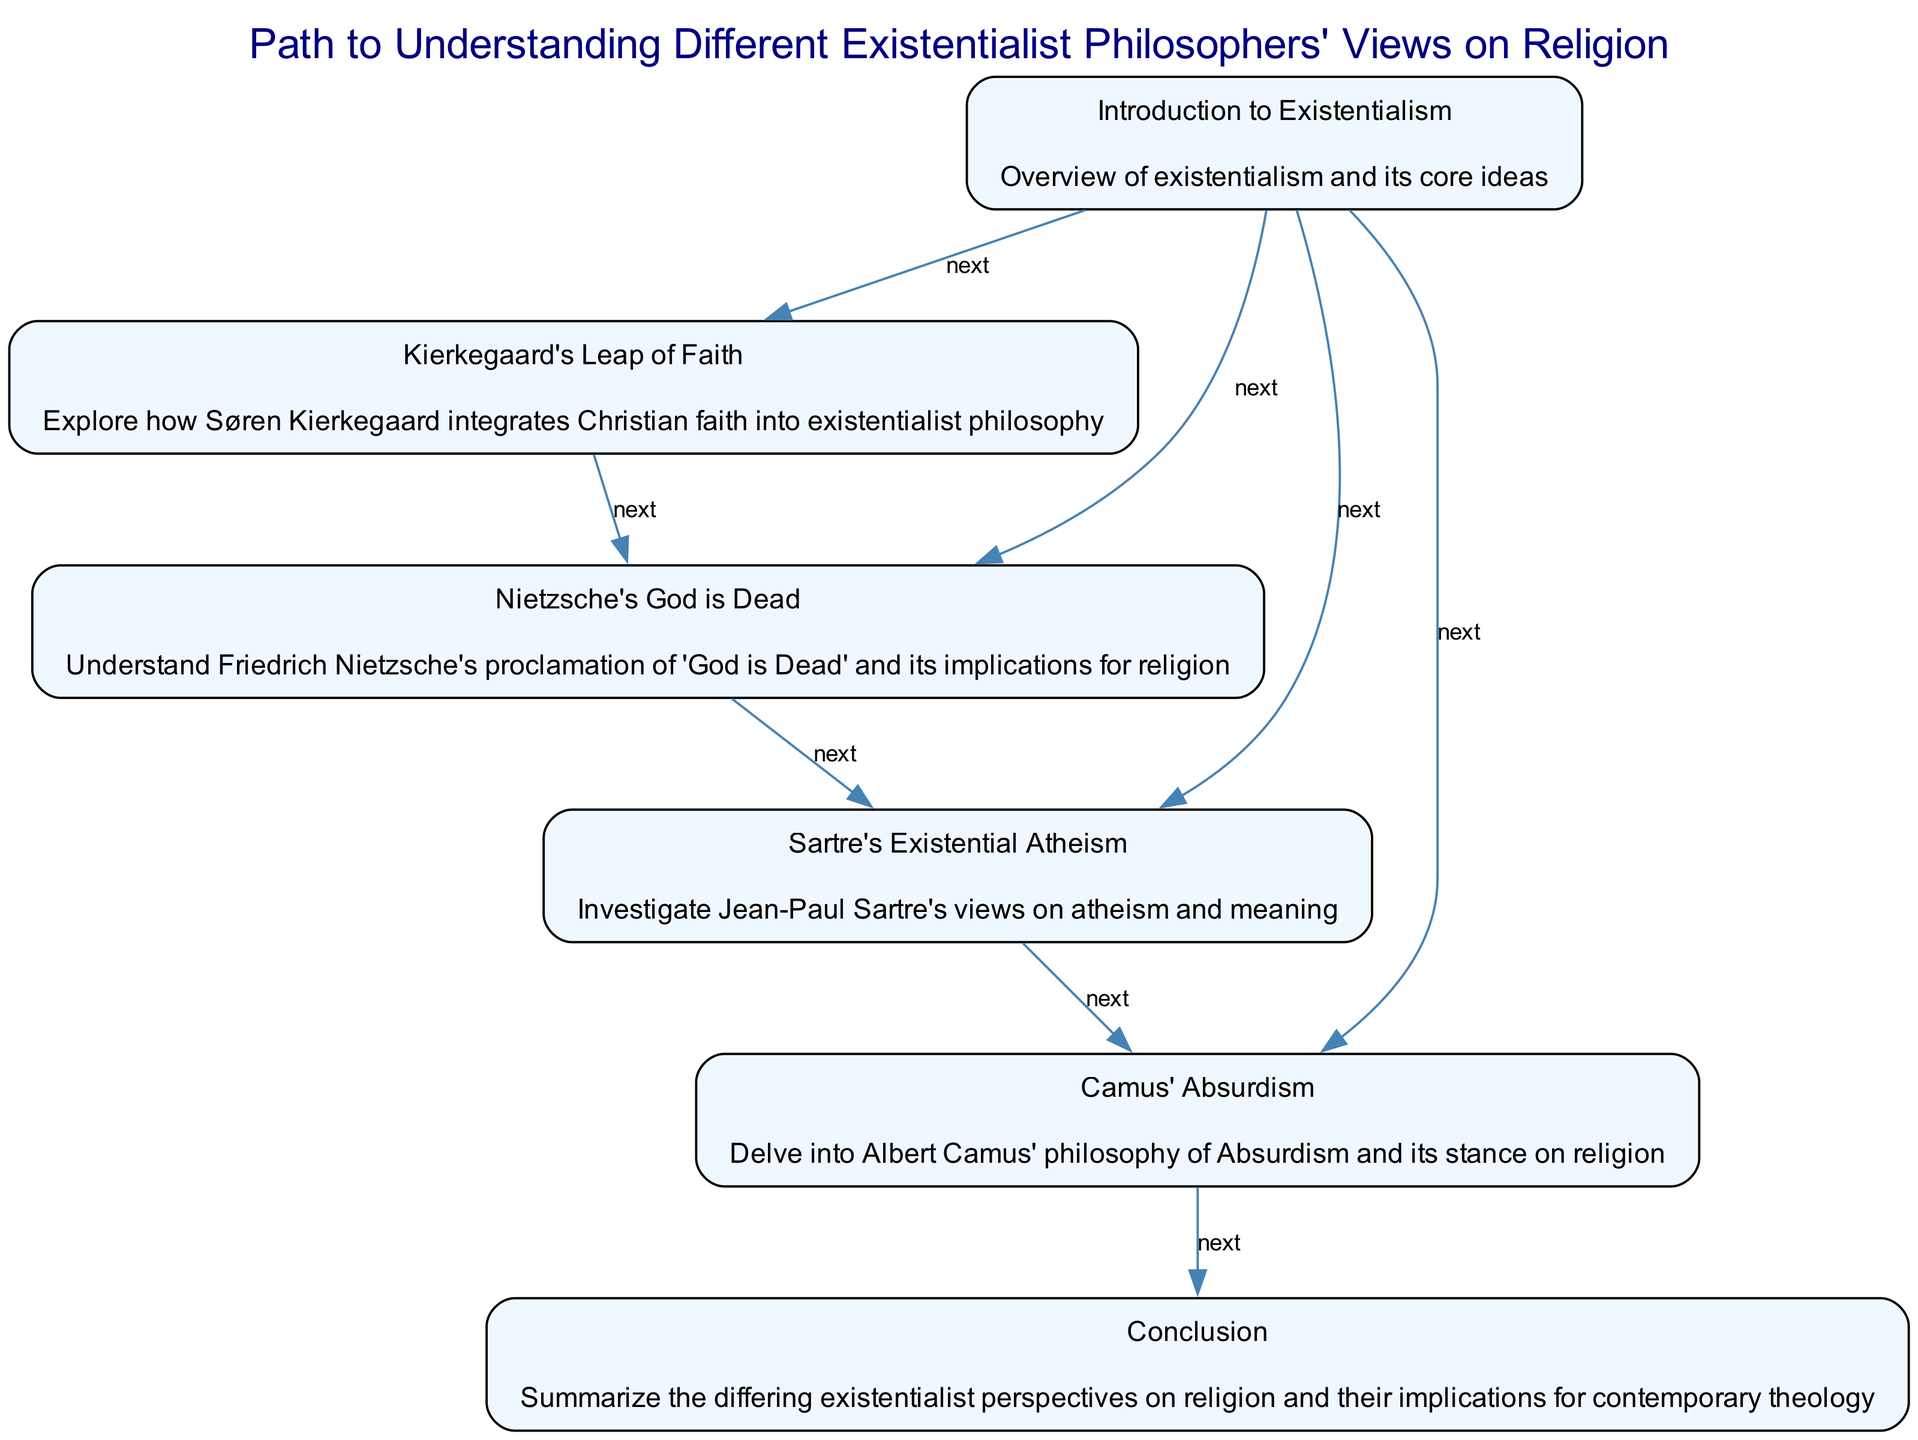What is the first node in the diagram? The first node is "Introduction to Existentialism", as per its position at the top of the flow chart.
Answer: Introduction to Existentialism How many nodes are present in the diagram? The diagram contains a total of six nodes: Introduction to Existentialism, Kierkegaard's Leap of Faith, Nietzsche's God is Dead, Sartre's Existential Atheism, Camus' Absurdism, and Conclusion.
Answer: Six What is the relationship between Sartre's Existential Atheism and Camus' Absurdism? Sartre's Existential Atheism has a "next" relationship to Camus' Absurdism, indicating that after understanding Sartre's view, one should proceed to Camus' philosophy.
Answer: next Which philosopher is associated with the concept of "God is Dead"? The philosopher associated with "God is Dead" is Friedrich Nietzsche, as indicated in the node under his name.
Answer: Friedrich Nietzsche What is the last node in the flow chart? The last node is "Conclusion", which summarizes the differing existentialist perspectives.
Answer: Conclusion Which philosopher's view comes immediately after Kierkegaard's Leap of Faith? The view that comes immediately after Kierkegaard's Leap of Faith is Nietzsche's God is Dead, as shown by the connection in the diagram.
Answer: Nietzsche's God is Dead Explain the path from Kierkegaard to the Conclusion. The path begins at Kierkegaard's Leap of Faith, leading to Nietzsche's God is Dead. From there, it proceeds to Sartre's Existential Atheism, followed by Camus' Absurdism, and finally culminates in the Conclusion node, summarizing the perspectives. This shows a continuous flow through the existentialist philosophers' views before reaching the final summary.
Answer: Kierkegaard's Leap of Faith → Nietzsche's God is Dead → Sartre's Existential Atheism → Camus' Absurdism → Conclusion 